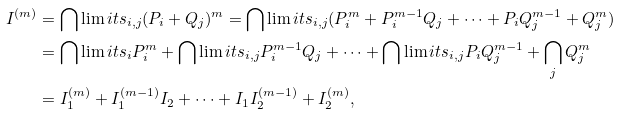<formula> <loc_0><loc_0><loc_500><loc_500>I ^ { ( m ) } & = \bigcap \lim i t s _ { i , j } ( P _ { i } + Q _ { j } ) ^ { m } = \bigcap \lim i t s _ { i , j } ( P _ { i } ^ { m } + P _ { i } ^ { m - 1 } Q _ { j } + \cdots + P _ { i } Q _ { j } ^ { m - 1 } + Q _ { j } ^ { m } ) \\ & = \bigcap \lim i t s _ { i } P _ { i } ^ { m } + \bigcap \lim i t s _ { i , j } P _ { i } ^ { m - 1 } Q _ { j } + \cdots + \bigcap \lim i t s _ { i , j } P _ { i } Q _ { j } ^ { m - 1 } + \bigcap _ { j } Q _ { j } ^ { m } \\ & = I _ { 1 } ^ { ( m ) } + I _ { 1 } ^ { ( m - 1 ) } I _ { 2 } + \cdots + I _ { 1 } I _ { 2 } ^ { ( m - 1 ) } + I _ { 2 } ^ { ( m ) } ,</formula> 